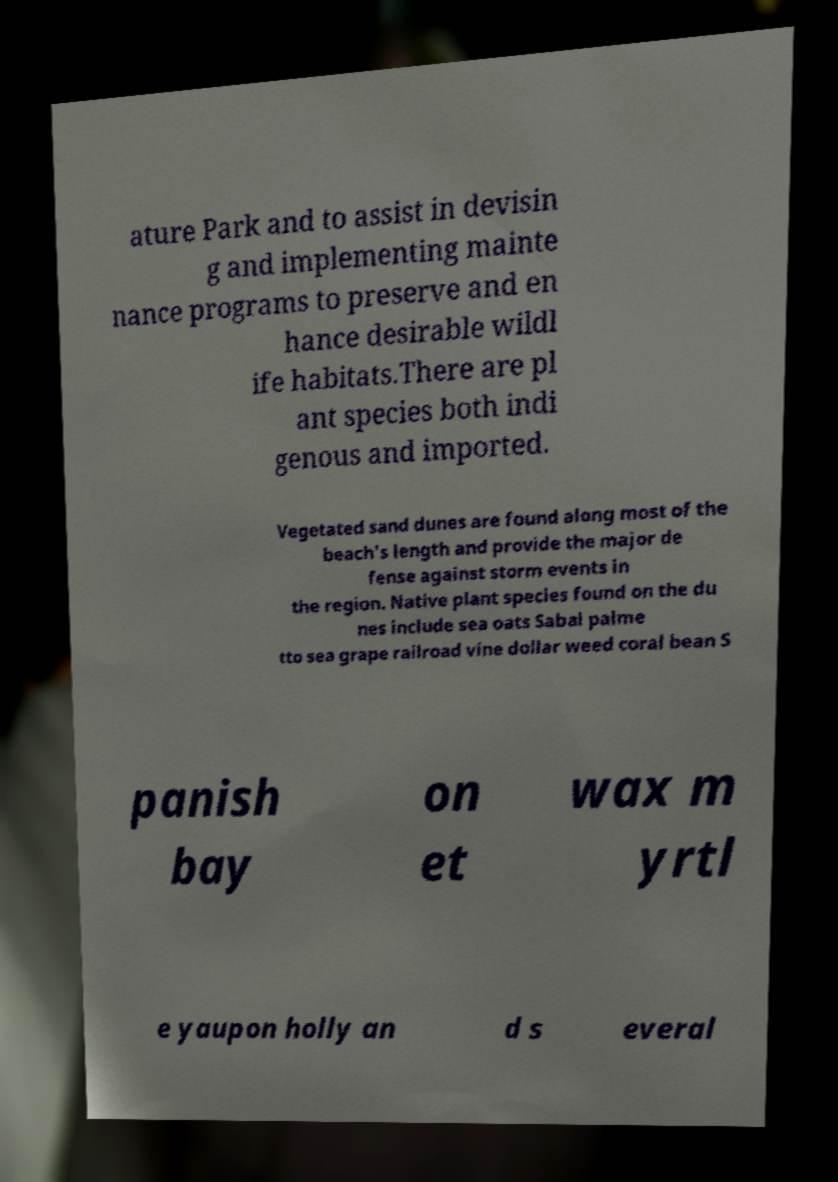For documentation purposes, I need the text within this image transcribed. Could you provide that? ature Park and to assist in devisin g and implementing mainte nance programs to preserve and en hance desirable wildl ife habitats.There are pl ant species both indi genous and imported. Vegetated sand dunes are found along most of the beach's length and provide the major de fense against storm events in the region. Native plant species found on the du nes include sea oats Sabal palme tto sea grape railroad vine dollar weed coral bean S panish bay on et wax m yrtl e yaupon holly an d s everal 